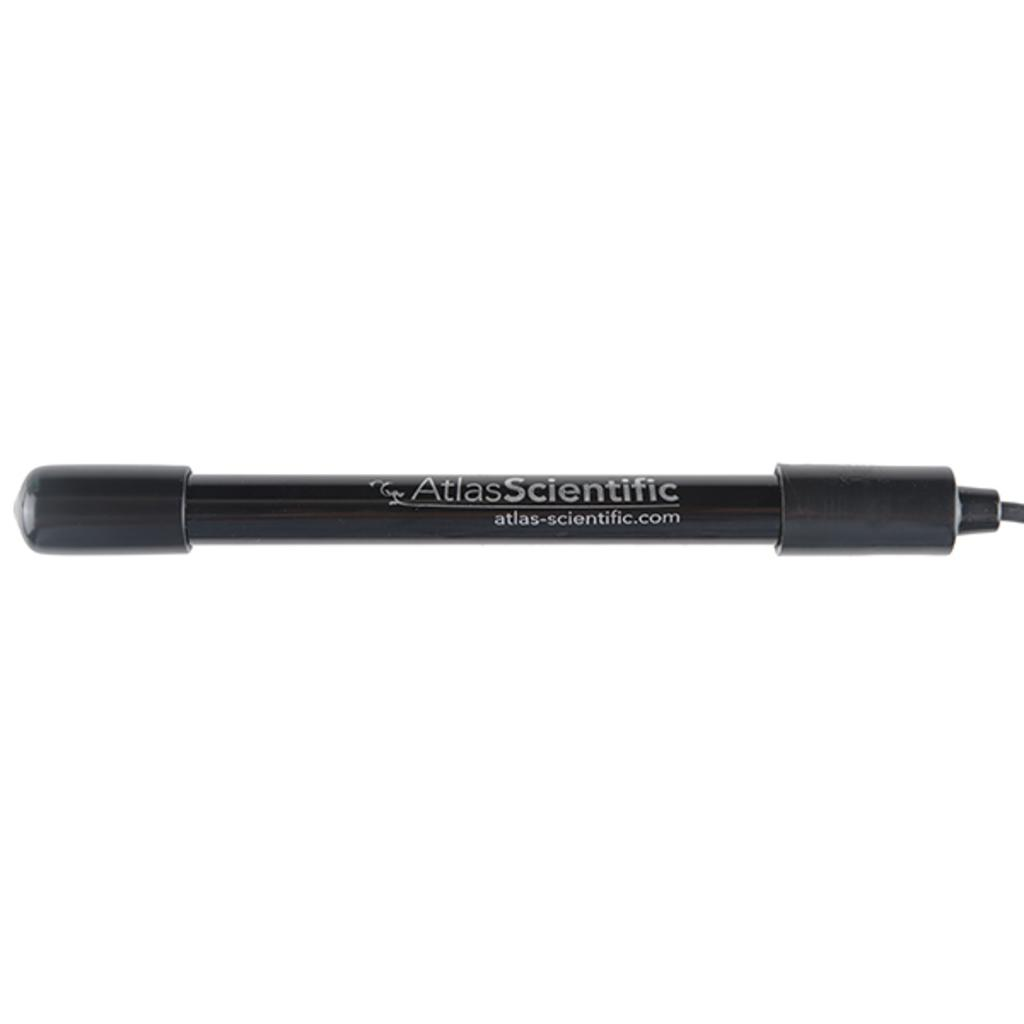What is the color of the main object in the image? The main object in the image is black. What is written on the black object? There is writing on the black object. What color is the background of the image? The background of the image is white. What type of lock is visible on the minister in the image? There is no minister or lock present in the image. What type of sink is visible in the image? There is no sink present in the image. 